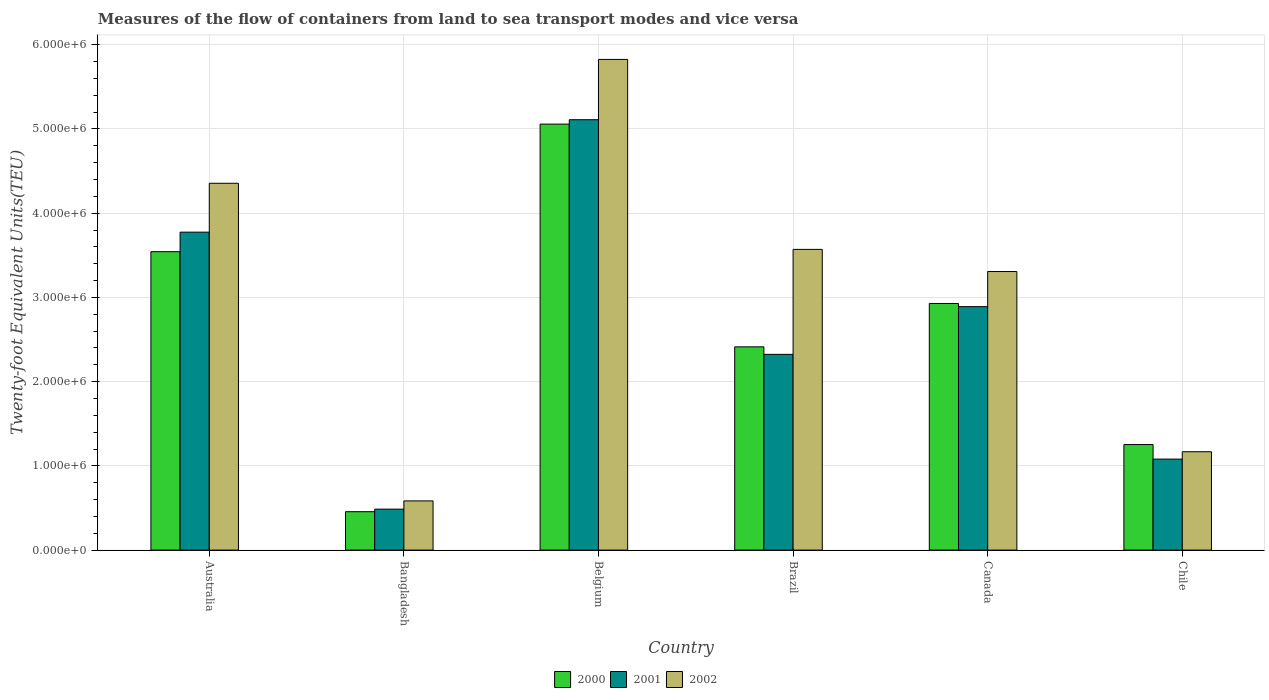How many groups of bars are there?
Give a very brief answer. 6. How many bars are there on the 2nd tick from the right?
Keep it short and to the point. 3. In how many cases, is the number of bars for a given country not equal to the number of legend labels?
Ensure brevity in your answer.  0. What is the container port traffic in 2002 in Belgium?
Provide a succinct answer. 5.83e+06. Across all countries, what is the maximum container port traffic in 2001?
Make the answer very short. 5.11e+06. Across all countries, what is the minimum container port traffic in 2000?
Make the answer very short. 4.56e+05. In which country was the container port traffic in 2001 maximum?
Your answer should be very brief. Belgium. In which country was the container port traffic in 2002 minimum?
Offer a very short reply. Bangladesh. What is the total container port traffic in 2002 in the graph?
Provide a succinct answer. 1.88e+07. What is the difference between the container port traffic in 2002 in Belgium and that in Brazil?
Offer a very short reply. 2.26e+06. What is the difference between the container port traffic in 2000 in Australia and the container port traffic in 2002 in Belgium?
Offer a very short reply. -2.28e+06. What is the average container port traffic in 2002 per country?
Make the answer very short. 3.14e+06. What is the difference between the container port traffic of/in 2001 and container port traffic of/in 2000 in Brazil?
Ensure brevity in your answer.  -8.93e+04. What is the ratio of the container port traffic in 2000 in Belgium to that in Canada?
Ensure brevity in your answer.  1.73. Is the container port traffic in 2000 in Australia less than that in Canada?
Your response must be concise. No. Is the difference between the container port traffic in 2001 in Bangladesh and Brazil greater than the difference between the container port traffic in 2000 in Bangladesh and Brazil?
Provide a succinct answer. Yes. What is the difference between the highest and the second highest container port traffic in 2002?
Your answer should be compact. 1.47e+06. What is the difference between the highest and the lowest container port traffic in 2000?
Provide a succinct answer. 4.60e+06. In how many countries, is the container port traffic in 2001 greater than the average container port traffic in 2001 taken over all countries?
Provide a succinct answer. 3. How many bars are there?
Offer a terse response. 18. How many countries are there in the graph?
Provide a succinct answer. 6. What is the difference between two consecutive major ticks on the Y-axis?
Your answer should be very brief. 1.00e+06. Are the values on the major ticks of Y-axis written in scientific E-notation?
Your answer should be very brief. Yes. Does the graph contain any zero values?
Make the answer very short. No. Where does the legend appear in the graph?
Offer a terse response. Bottom center. How many legend labels are there?
Offer a very short reply. 3. What is the title of the graph?
Keep it short and to the point. Measures of the flow of containers from land to sea transport modes and vice versa. Does "1965" appear as one of the legend labels in the graph?
Your answer should be compact. No. What is the label or title of the X-axis?
Provide a succinct answer. Country. What is the label or title of the Y-axis?
Ensure brevity in your answer.  Twenty-foot Equivalent Units(TEU). What is the Twenty-foot Equivalent Units(TEU) of 2000 in Australia?
Your response must be concise. 3.54e+06. What is the Twenty-foot Equivalent Units(TEU) of 2001 in Australia?
Provide a succinct answer. 3.77e+06. What is the Twenty-foot Equivalent Units(TEU) of 2002 in Australia?
Your response must be concise. 4.36e+06. What is the Twenty-foot Equivalent Units(TEU) in 2000 in Bangladesh?
Ensure brevity in your answer.  4.56e+05. What is the Twenty-foot Equivalent Units(TEU) in 2001 in Bangladesh?
Your response must be concise. 4.86e+05. What is the Twenty-foot Equivalent Units(TEU) in 2002 in Bangladesh?
Your answer should be very brief. 5.84e+05. What is the Twenty-foot Equivalent Units(TEU) in 2000 in Belgium?
Provide a succinct answer. 5.06e+06. What is the Twenty-foot Equivalent Units(TEU) in 2001 in Belgium?
Offer a very short reply. 5.11e+06. What is the Twenty-foot Equivalent Units(TEU) of 2002 in Belgium?
Your response must be concise. 5.83e+06. What is the Twenty-foot Equivalent Units(TEU) in 2000 in Brazil?
Provide a short and direct response. 2.41e+06. What is the Twenty-foot Equivalent Units(TEU) of 2001 in Brazil?
Offer a terse response. 2.32e+06. What is the Twenty-foot Equivalent Units(TEU) in 2002 in Brazil?
Give a very brief answer. 3.57e+06. What is the Twenty-foot Equivalent Units(TEU) in 2000 in Canada?
Your answer should be very brief. 2.93e+06. What is the Twenty-foot Equivalent Units(TEU) in 2001 in Canada?
Your answer should be compact. 2.89e+06. What is the Twenty-foot Equivalent Units(TEU) in 2002 in Canada?
Make the answer very short. 3.31e+06. What is the Twenty-foot Equivalent Units(TEU) in 2000 in Chile?
Keep it short and to the point. 1.25e+06. What is the Twenty-foot Equivalent Units(TEU) of 2001 in Chile?
Offer a terse response. 1.08e+06. What is the Twenty-foot Equivalent Units(TEU) in 2002 in Chile?
Provide a succinct answer. 1.17e+06. Across all countries, what is the maximum Twenty-foot Equivalent Units(TEU) in 2000?
Keep it short and to the point. 5.06e+06. Across all countries, what is the maximum Twenty-foot Equivalent Units(TEU) in 2001?
Offer a very short reply. 5.11e+06. Across all countries, what is the maximum Twenty-foot Equivalent Units(TEU) in 2002?
Give a very brief answer. 5.83e+06. Across all countries, what is the minimum Twenty-foot Equivalent Units(TEU) of 2000?
Offer a very short reply. 4.56e+05. Across all countries, what is the minimum Twenty-foot Equivalent Units(TEU) of 2001?
Give a very brief answer. 4.86e+05. Across all countries, what is the minimum Twenty-foot Equivalent Units(TEU) in 2002?
Ensure brevity in your answer.  5.84e+05. What is the total Twenty-foot Equivalent Units(TEU) in 2000 in the graph?
Offer a terse response. 1.57e+07. What is the total Twenty-foot Equivalent Units(TEU) of 2001 in the graph?
Offer a terse response. 1.57e+07. What is the total Twenty-foot Equivalent Units(TEU) of 2002 in the graph?
Your answer should be compact. 1.88e+07. What is the difference between the Twenty-foot Equivalent Units(TEU) in 2000 in Australia and that in Bangladesh?
Make the answer very short. 3.09e+06. What is the difference between the Twenty-foot Equivalent Units(TEU) of 2001 in Australia and that in Bangladesh?
Your answer should be very brief. 3.29e+06. What is the difference between the Twenty-foot Equivalent Units(TEU) in 2002 in Australia and that in Bangladesh?
Give a very brief answer. 3.77e+06. What is the difference between the Twenty-foot Equivalent Units(TEU) of 2000 in Australia and that in Belgium?
Offer a very short reply. -1.51e+06. What is the difference between the Twenty-foot Equivalent Units(TEU) of 2001 in Australia and that in Belgium?
Offer a terse response. -1.33e+06. What is the difference between the Twenty-foot Equivalent Units(TEU) in 2002 in Australia and that in Belgium?
Provide a short and direct response. -1.47e+06. What is the difference between the Twenty-foot Equivalent Units(TEU) of 2000 in Australia and that in Brazil?
Offer a terse response. 1.13e+06. What is the difference between the Twenty-foot Equivalent Units(TEU) in 2001 in Australia and that in Brazil?
Keep it short and to the point. 1.45e+06. What is the difference between the Twenty-foot Equivalent Units(TEU) in 2002 in Australia and that in Brazil?
Offer a very short reply. 7.85e+05. What is the difference between the Twenty-foot Equivalent Units(TEU) in 2000 in Australia and that in Canada?
Your answer should be compact. 6.15e+05. What is the difference between the Twenty-foot Equivalent Units(TEU) of 2001 in Australia and that in Canada?
Give a very brief answer. 8.84e+05. What is the difference between the Twenty-foot Equivalent Units(TEU) of 2002 in Australia and that in Canada?
Your answer should be compact. 1.05e+06. What is the difference between the Twenty-foot Equivalent Units(TEU) of 2000 in Australia and that in Chile?
Offer a very short reply. 2.29e+06. What is the difference between the Twenty-foot Equivalent Units(TEU) in 2001 in Australia and that in Chile?
Provide a succinct answer. 2.69e+06. What is the difference between the Twenty-foot Equivalent Units(TEU) in 2002 in Australia and that in Chile?
Your answer should be compact. 3.19e+06. What is the difference between the Twenty-foot Equivalent Units(TEU) of 2000 in Bangladesh and that in Belgium?
Provide a succinct answer. -4.60e+06. What is the difference between the Twenty-foot Equivalent Units(TEU) in 2001 in Bangladesh and that in Belgium?
Provide a short and direct response. -4.62e+06. What is the difference between the Twenty-foot Equivalent Units(TEU) of 2002 in Bangladesh and that in Belgium?
Offer a terse response. -5.24e+06. What is the difference between the Twenty-foot Equivalent Units(TEU) of 2000 in Bangladesh and that in Brazil?
Provide a short and direct response. -1.96e+06. What is the difference between the Twenty-foot Equivalent Units(TEU) of 2001 in Bangladesh and that in Brazil?
Give a very brief answer. -1.84e+06. What is the difference between the Twenty-foot Equivalent Units(TEU) in 2002 in Bangladesh and that in Brazil?
Your response must be concise. -2.99e+06. What is the difference between the Twenty-foot Equivalent Units(TEU) of 2000 in Bangladesh and that in Canada?
Your answer should be very brief. -2.47e+06. What is the difference between the Twenty-foot Equivalent Units(TEU) in 2001 in Bangladesh and that in Canada?
Give a very brief answer. -2.40e+06. What is the difference between the Twenty-foot Equivalent Units(TEU) of 2002 in Bangladesh and that in Canada?
Make the answer very short. -2.72e+06. What is the difference between the Twenty-foot Equivalent Units(TEU) of 2000 in Bangladesh and that in Chile?
Your answer should be compact. -7.97e+05. What is the difference between the Twenty-foot Equivalent Units(TEU) in 2001 in Bangladesh and that in Chile?
Keep it short and to the point. -5.94e+05. What is the difference between the Twenty-foot Equivalent Units(TEU) in 2002 in Bangladesh and that in Chile?
Keep it short and to the point. -5.84e+05. What is the difference between the Twenty-foot Equivalent Units(TEU) of 2000 in Belgium and that in Brazil?
Your answer should be very brief. 2.64e+06. What is the difference between the Twenty-foot Equivalent Units(TEU) of 2001 in Belgium and that in Brazil?
Your response must be concise. 2.79e+06. What is the difference between the Twenty-foot Equivalent Units(TEU) in 2002 in Belgium and that in Brazil?
Make the answer very short. 2.26e+06. What is the difference between the Twenty-foot Equivalent Units(TEU) in 2000 in Belgium and that in Canada?
Keep it short and to the point. 2.13e+06. What is the difference between the Twenty-foot Equivalent Units(TEU) in 2001 in Belgium and that in Canada?
Make the answer very short. 2.22e+06. What is the difference between the Twenty-foot Equivalent Units(TEU) of 2002 in Belgium and that in Canada?
Provide a short and direct response. 2.52e+06. What is the difference between the Twenty-foot Equivalent Units(TEU) in 2000 in Belgium and that in Chile?
Offer a terse response. 3.80e+06. What is the difference between the Twenty-foot Equivalent Units(TEU) of 2001 in Belgium and that in Chile?
Make the answer very short. 4.03e+06. What is the difference between the Twenty-foot Equivalent Units(TEU) of 2002 in Belgium and that in Chile?
Give a very brief answer. 4.66e+06. What is the difference between the Twenty-foot Equivalent Units(TEU) of 2000 in Brazil and that in Canada?
Ensure brevity in your answer.  -5.15e+05. What is the difference between the Twenty-foot Equivalent Units(TEU) in 2001 in Brazil and that in Canada?
Offer a very short reply. -5.67e+05. What is the difference between the Twenty-foot Equivalent Units(TEU) of 2002 in Brazil and that in Canada?
Make the answer very short. 2.63e+05. What is the difference between the Twenty-foot Equivalent Units(TEU) of 2000 in Brazil and that in Chile?
Your response must be concise. 1.16e+06. What is the difference between the Twenty-foot Equivalent Units(TEU) in 2001 in Brazil and that in Chile?
Offer a very short reply. 1.24e+06. What is the difference between the Twenty-foot Equivalent Units(TEU) of 2002 in Brazil and that in Chile?
Keep it short and to the point. 2.40e+06. What is the difference between the Twenty-foot Equivalent Units(TEU) of 2000 in Canada and that in Chile?
Ensure brevity in your answer.  1.67e+06. What is the difference between the Twenty-foot Equivalent Units(TEU) in 2001 in Canada and that in Chile?
Your answer should be very brief. 1.81e+06. What is the difference between the Twenty-foot Equivalent Units(TEU) of 2002 in Canada and that in Chile?
Offer a very short reply. 2.14e+06. What is the difference between the Twenty-foot Equivalent Units(TEU) in 2000 in Australia and the Twenty-foot Equivalent Units(TEU) in 2001 in Bangladesh?
Make the answer very short. 3.06e+06. What is the difference between the Twenty-foot Equivalent Units(TEU) of 2000 in Australia and the Twenty-foot Equivalent Units(TEU) of 2002 in Bangladesh?
Provide a short and direct response. 2.96e+06. What is the difference between the Twenty-foot Equivalent Units(TEU) in 2001 in Australia and the Twenty-foot Equivalent Units(TEU) in 2002 in Bangladesh?
Offer a very short reply. 3.19e+06. What is the difference between the Twenty-foot Equivalent Units(TEU) of 2000 in Australia and the Twenty-foot Equivalent Units(TEU) of 2001 in Belgium?
Your answer should be very brief. -1.57e+06. What is the difference between the Twenty-foot Equivalent Units(TEU) in 2000 in Australia and the Twenty-foot Equivalent Units(TEU) in 2002 in Belgium?
Your answer should be very brief. -2.28e+06. What is the difference between the Twenty-foot Equivalent Units(TEU) of 2001 in Australia and the Twenty-foot Equivalent Units(TEU) of 2002 in Belgium?
Make the answer very short. -2.05e+06. What is the difference between the Twenty-foot Equivalent Units(TEU) in 2000 in Australia and the Twenty-foot Equivalent Units(TEU) in 2001 in Brazil?
Your response must be concise. 1.22e+06. What is the difference between the Twenty-foot Equivalent Units(TEU) of 2000 in Australia and the Twenty-foot Equivalent Units(TEU) of 2002 in Brazil?
Your answer should be very brief. -2.75e+04. What is the difference between the Twenty-foot Equivalent Units(TEU) of 2001 in Australia and the Twenty-foot Equivalent Units(TEU) of 2002 in Brazil?
Offer a very short reply. 2.05e+05. What is the difference between the Twenty-foot Equivalent Units(TEU) of 2000 in Australia and the Twenty-foot Equivalent Units(TEU) of 2001 in Canada?
Offer a terse response. 6.52e+05. What is the difference between the Twenty-foot Equivalent Units(TEU) in 2000 in Australia and the Twenty-foot Equivalent Units(TEU) in 2002 in Canada?
Ensure brevity in your answer.  2.35e+05. What is the difference between the Twenty-foot Equivalent Units(TEU) in 2001 in Australia and the Twenty-foot Equivalent Units(TEU) in 2002 in Canada?
Offer a very short reply. 4.68e+05. What is the difference between the Twenty-foot Equivalent Units(TEU) of 2000 in Australia and the Twenty-foot Equivalent Units(TEU) of 2001 in Chile?
Provide a short and direct response. 2.46e+06. What is the difference between the Twenty-foot Equivalent Units(TEU) in 2000 in Australia and the Twenty-foot Equivalent Units(TEU) in 2002 in Chile?
Provide a short and direct response. 2.37e+06. What is the difference between the Twenty-foot Equivalent Units(TEU) in 2001 in Australia and the Twenty-foot Equivalent Units(TEU) in 2002 in Chile?
Provide a short and direct response. 2.61e+06. What is the difference between the Twenty-foot Equivalent Units(TEU) of 2000 in Bangladesh and the Twenty-foot Equivalent Units(TEU) of 2001 in Belgium?
Offer a terse response. -4.65e+06. What is the difference between the Twenty-foot Equivalent Units(TEU) in 2000 in Bangladesh and the Twenty-foot Equivalent Units(TEU) in 2002 in Belgium?
Offer a terse response. -5.37e+06. What is the difference between the Twenty-foot Equivalent Units(TEU) in 2001 in Bangladesh and the Twenty-foot Equivalent Units(TEU) in 2002 in Belgium?
Offer a terse response. -5.34e+06. What is the difference between the Twenty-foot Equivalent Units(TEU) of 2000 in Bangladesh and the Twenty-foot Equivalent Units(TEU) of 2001 in Brazil?
Provide a succinct answer. -1.87e+06. What is the difference between the Twenty-foot Equivalent Units(TEU) of 2000 in Bangladesh and the Twenty-foot Equivalent Units(TEU) of 2002 in Brazil?
Provide a short and direct response. -3.11e+06. What is the difference between the Twenty-foot Equivalent Units(TEU) in 2001 in Bangladesh and the Twenty-foot Equivalent Units(TEU) in 2002 in Brazil?
Ensure brevity in your answer.  -3.08e+06. What is the difference between the Twenty-foot Equivalent Units(TEU) of 2000 in Bangladesh and the Twenty-foot Equivalent Units(TEU) of 2001 in Canada?
Your response must be concise. -2.43e+06. What is the difference between the Twenty-foot Equivalent Units(TEU) of 2000 in Bangladesh and the Twenty-foot Equivalent Units(TEU) of 2002 in Canada?
Your answer should be compact. -2.85e+06. What is the difference between the Twenty-foot Equivalent Units(TEU) in 2001 in Bangladesh and the Twenty-foot Equivalent Units(TEU) in 2002 in Canada?
Give a very brief answer. -2.82e+06. What is the difference between the Twenty-foot Equivalent Units(TEU) of 2000 in Bangladesh and the Twenty-foot Equivalent Units(TEU) of 2001 in Chile?
Your answer should be very brief. -6.25e+05. What is the difference between the Twenty-foot Equivalent Units(TEU) of 2000 in Bangladesh and the Twenty-foot Equivalent Units(TEU) of 2002 in Chile?
Offer a terse response. -7.12e+05. What is the difference between the Twenty-foot Equivalent Units(TEU) of 2001 in Bangladesh and the Twenty-foot Equivalent Units(TEU) of 2002 in Chile?
Give a very brief answer. -6.82e+05. What is the difference between the Twenty-foot Equivalent Units(TEU) in 2000 in Belgium and the Twenty-foot Equivalent Units(TEU) in 2001 in Brazil?
Your answer should be compact. 2.73e+06. What is the difference between the Twenty-foot Equivalent Units(TEU) of 2000 in Belgium and the Twenty-foot Equivalent Units(TEU) of 2002 in Brazil?
Give a very brief answer. 1.49e+06. What is the difference between the Twenty-foot Equivalent Units(TEU) in 2001 in Belgium and the Twenty-foot Equivalent Units(TEU) in 2002 in Brazil?
Provide a succinct answer. 1.54e+06. What is the difference between the Twenty-foot Equivalent Units(TEU) in 2000 in Belgium and the Twenty-foot Equivalent Units(TEU) in 2001 in Canada?
Your response must be concise. 2.17e+06. What is the difference between the Twenty-foot Equivalent Units(TEU) in 2000 in Belgium and the Twenty-foot Equivalent Units(TEU) in 2002 in Canada?
Your answer should be very brief. 1.75e+06. What is the difference between the Twenty-foot Equivalent Units(TEU) in 2001 in Belgium and the Twenty-foot Equivalent Units(TEU) in 2002 in Canada?
Keep it short and to the point. 1.80e+06. What is the difference between the Twenty-foot Equivalent Units(TEU) in 2000 in Belgium and the Twenty-foot Equivalent Units(TEU) in 2001 in Chile?
Offer a terse response. 3.98e+06. What is the difference between the Twenty-foot Equivalent Units(TEU) of 2000 in Belgium and the Twenty-foot Equivalent Units(TEU) of 2002 in Chile?
Keep it short and to the point. 3.89e+06. What is the difference between the Twenty-foot Equivalent Units(TEU) in 2001 in Belgium and the Twenty-foot Equivalent Units(TEU) in 2002 in Chile?
Your answer should be compact. 3.94e+06. What is the difference between the Twenty-foot Equivalent Units(TEU) of 2000 in Brazil and the Twenty-foot Equivalent Units(TEU) of 2001 in Canada?
Your answer should be compact. -4.77e+05. What is the difference between the Twenty-foot Equivalent Units(TEU) in 2000 in Brazil and the Twenty-foot Equivalent Units(TEU) in 2002 in Canada?
Provide a succinct answer. -8.94e+05. What is the difference between the Twenty-foot Equivalent Units(TEU) in 2001 in Brazil and the Twenty-foot Equivalent Units(TEU) in 2002 in Canada?
Offer a very short reply. -9.84e+05. What is the difference between the Twenty-foot Equivalent Units(TEU) in 2000 in Brazil and the Twenty-foot Equivalent Units(TEU) in 2001 in Chile?
Make the answer very short. 1.33e+06. What is the difference between the Twenty-foot Equivalent Units(TEU) of 2000 in Brazil and the Twenty-foot Equivalent Units(TEU) of 2002 in Chile?
Give a very brief answer. 1.25e+06. What is the difference between the Twenty-foot Equivalent Units(TEU) in 2001 in Brazil and the Twenty-foot Equivalent Units(TEU) in 2002 in Chile?
Ensure brevity in your answer.  1.16e+06. What is the difference between the Twenty-foot Equivalent Units(TEU) of 2000 in Canada and the Twenty-foot Equivalent Units(TEU) of 2001 in Chile?
Give a very brief answer. 1.85e+06. What is the difference between the Twenty-foot Equivalent Units(TEU) of 2000 in Canada and the Twenty-foot Equivalent Units(TEU) of 2002 in Chile?
Provide a succinct answer. 1.76e+06. What is the difference between the Twenty-foot Equivalent Units(TEU) in 2001 in Canada and the Twenty-foot Equivalent Units(TEU) in 2002 in Chile?
Offer a terse response. 1.72e+06. What is the average Twenty-foot Equivalent Units(TEU) in 2000 per country?
Give a very brief answer. 2.61e+06. What is the average Twenty-foot Equivalent Units(TEU) in 2001 per country?
Your answer should be compact. 2.61e+06. What is the average Twenty-foot Equivalent Units(TEU) of 2002 per country?
Your response must be concise. 3.14e+06. What is the difference between the Twenty-foot Equivalent Units(TEU) of 2000 and Twenty-foot Equivalent Units(TEU) of 2001 in Australia?
Offer a terse response. -2.32e+05. What is the difference between the Twenty-foot Equivalent Units(TEU) of 2000 and Twenty-foot Equivalent Units(TEU) of 2002 in Australia?
Ensure brevity in your answer.  -8.12e+05. What is the difference between the Twenty-foot Equivalent Units(TEU) in 2001 and Twenty-foot Equivalent Units(TEU) in 2002 in Australia?
Offer a terse response. -5.80e+05. What is the difference between the Twenty-foot Equivalent Units(TEU) of 2000 and Twenty-foot Equivalent Units(TEU) of 2001 in Bangladesh?
Ensure brevity in your answer.  -3.03e+04. What is the difference between the Twenty-foot Equivalent Units(TEU) of 2000 and Twenty-foot Equivalent Units(TEU) of 2002 in Bangladesh?
Your answer should be compact. -1.28e+05. What is the difference between the Twenty-foot Equivalent Units(TEU) of 2001 and Twenty-foot Equivalent Units(TEU) of 2002 in Bangladesh?
Your answer should be compact. -9.79e+04. What is the difference between the Twenty-foot Equivalent Units(TEU) in 2000 and Twenty-foot Equivalent Units(TEU) in 2001 in Belgium?
Give a very brief answer. -5.21e+04. What is the difference between the Twenty-foot Equivalent Units(TEU) of 2000 and Twenty-foot Equivalent Units(TEU) of 2002 in Belgium?
Your response must be concise. -7.68e+05. What is the difference between the Twenty-foot Equivalent Units(TEU) in 2001 and Twenty-foot Equivalent Units(TEU) in 2002 in Belgium?
Offer a terse response. -7.16e+05. What is the difference between the Twenty-foot Equivalent Units(TEU) in 2000 and Twenty-foot Equivalent Units(TEU) in 2001 in Brazil?
Provide a short and direct response. 8.93e+04. What is the difference between the Twenty-foot Equivalent Units(TEU) of 2000 and Twenty-foot Equivalent Units(TEU) of 2002 in Brazil?
Ensure brevity in your answer.  -1.16e+06. What is the difference between the Twenty-foot Equivalent Units(TEU) of 2001 and Twenty-foot Equivalent Units(TEU) of 2002 in Brazil?
Keep it short and to the point. -1.25e+06. What is the difference between the Twenty-foot Equivalent Units(TEU) in 2000 and Twenty-foot Equivalent Units(TEU) in 2001 in Canada?
Your answer should be compact. 3.76e+04. What is the difference between the Twenty-foot Equivalent Units(TEU) of 2000 and Twenty-foot Equivalent Units(TEU) of 2002 in Canada?
Your answer should be very brief. -3.79e+05. What is the difference between the Twenty-foot Equivalent Units(TEU) of 2001 and Twenty-foot Equivalent Units(TEU) of 2002 in Canada?
Provide a succinct answer. -4.17e+05. What is the difference between the Twenty-foot Equivalent Units(TEU) of 2000 and Twenty-foot Equivalent Units(TEU) of 2001 in Chile?
Keep it short and to the point. 1.73e+05. What is the difference between the Twenty-foot Equivalent Units(TEU) of 2000 and Twenty-foot Equivalent Units(TEU) of 2002 in Chile?
Your answer should be compact. 8.53e+04. What is the difference between the Twenty-foot Equivalent Units(TEU) of 2001 and Twenty-foot Equivalent Units(TEU) of 2002 in Chile?
Make the answer very short. -8.73e+04. What is the ratio of the Twenty-foot Equivalent Units(TEU) in 2000 in Australia to that in Bangladesh?
Your answer should be compact. 7.77. What is the ratio of the Twenty-foot Equivalent Units(TEU) in 2001 in Australia to that in Bangladesh?
Ensure brevity in your answer.  7.76. What is the ratio of the Twenty-foot Equivalent Units(TEU) of 2002 in Australia to that in Bangladesh?
Your response must be concise. 7.45. What is the ratio of the Twenty-foot Equivalent Units(TEU) in 2000 in Australia to that in Belgium?
Give a very brief answer. 0.7. What is the ratio of the Twenty-foot Equivalent Units(TEU) in 2001 in Australia to that in Belgium?
Your answer should be compact. 0.74. What is the ratio of the Twenty-foot Equivalent Units(TEU) of 2002 in Australia to that in Belgium?
Provide a short and direct response. 0.75. What is the ratio of the Twenty-foot Equivalent Units(TEU) of 2000 in Australia to that in Brazil?
Keep it short and to the point. 1.47. What is the ratio of the Twenty-foot Equivalent Units(TEU) of 2001 in Australia to that in Brazil?
Offer a very short reply. 1.62. What is the ratio of the Twenty-foot Equivalent Units(TEU) in 2002 in Australia to that in Brazil?
Your answer should be compact. 1.22. What is the ratio of the Twenty-foot Equivalent Units(TEU) in 2000 in Australia to that in Canada?
Provide a succinct answer. 1.21. What is the ratio of the Twenty-foot Equivalent Units(TEU) of 2001 in Australia to that in Canada?
Your response must be concise. 1.31. What is the ratio of the Twenty-foot Equivalent Units(TEU) in 2002 in Australia to that in Canada?
Ensure brevity in your answer.  1.32. What is the ratio of the Twenty-foot Equivalent Units(TEU) of 2000 in Australia to that in Chile?
Provide a succinct answer. 2.83. What is the ratio of the Twenty-foot Equivalent Units(TEU) of 2001 in Australia to that in Chile?
Provide a succinct answer. 3.49. What is the ratio of the Twenty-foot Equivalent Units(TEU) in 2002 in Australia to that in Chile?
Provide a succinct answer. 3.73. What is the ratio of the Twenty-foot Equivalent Units(TEU) in 2000 in Bangladesh to that in Belgium?
Offer a very short reply. 0.09. What is the ratio of the Twenty-foot Equivalent Units(TEU) of 2001 in Bangladesh to that in Belgium?
Your response must be concise. 0.1. What is the ratio of the Twenty-foot Equivalent Units(TEU) of 2002 in Bangladesh to that in Belgium?
Provide a short and direct response. 0.1. What is the ratio of the Twenty-foot Equivalent Units(TEU) of 2000 in Bangladesh to that in Brazil?
Your response must be concise. 0.19. What is the ratio of the Twenty-foot Equivalent Units(TEU) of 2001 in Bangladesh to that in Brazil?
Your response must be concise. 0.21. What is the ratio of the Twenty-foot Equivalent Units(TEU) in 2002 in Bangladesh to that in Brazil?
Offer a very short reply. 0.16. What is the ratio of the Twenty-foot Equivalent Units(TEU) in 2000 in Bangladesh to that in Canada?
Provide a short and direct response. 0.16. What is the ratio of the Twenty-foot Equivalent Units(TEU) of 2001 in Bangladesh to that in Canada?
Give a very brief answer. 0.17. What is the ratio of the Twenty-foot Equivalent Units(TEU) in 2002 in Bangladesh to that in Canada?
Give a very brief answer. 0.18. What is the ratio of the Twenty-foot Equivalent Units(TEU) of 2000 in Bangladesh to that in Chile?
Your answer should be compact. 0.36. What is the ratio of the Twenty-foot Equivalent Units(TEU) of 2001 in Bangladesh to that in Chile?
Offer a terse response. 0.45. What is the ratio of the Twenty-foot Equivalent Units(TEU) in 2002 in Bangladesh to that in Chile?
Your response must be concise. 0.5. What is the ratio of the Twenty-foot Equivalent Units(TEU) in 2000 in Belgium to that in Brazil?
Your answer should be very brief. 2.1. What is the ratio of the Twenty-foot Equivalent Units(TEU) of 2001 in Belgium to that in Brazil?
Provide a short and direct response. 2.2. What is the ratio of the Twenty-foot Equivalent Units(TEU) of 2002 in Belgium to that in Brazil?
Offer a terse response. 1.63. What is the ratio of the Twenty-foot Equivalent Units(TEU) in 2000 in Belgium to that in Canada?
Make the answer very short. 1.73. What is the ratio of the Twenty-foot Equivalent Units(TEU) of 2001 in Belgium to that in Canada?
Your answer should be very brief. 1.77. What is the ratio of the Twenty-foot Equivalent Units(TEU) in 2002 in Belgium to that in Canada?
Provide a succinct answer. 1.76. What is the ratio of the Twenty-foot Equivalent Units(TEU) in 2000 in Belgium to that in Chile?
Keep it short and to the point. 4.04. What is the ratio of the Twenty-foot Equivalent Units(TEU) in 2001 in Belgium to that in Chile?
Give a very brief answer. 4.73. What is the ratio of the Twenty-foot Equivalent Units(TEU) of 2002 in Belgium to that in Chile?
Your response must be concise. 4.99. What is the ratio of the Twenty-foot Equivalent Units(TEU) of 2000 in Brazil to that in Canada?
Your answer should be compact. 0.82. What is the ratio of the Twenty-foot Equivalent Units(TEU) of 2001 in Brazil to that in Canada?
Offer a very short reply. 0.8. What is the ratio of the Twenty-foot Equivalent Units(TEU) of 2002 in Brazil to that in Canada?
Offer a very short reply. 1.08. What is the ratio of the Twenty-foot Equivalent Units(TEU) in 2000 in Brazil to that in Chile?
Give a very brief answer. 1.93. What is the ratio of the Twenty-foot Equivalent Units(TEU) in 2001 in Brazil to that in Chile?
Give a very brief answer. 2.15. What is the ratio of the Twenty-foot Equivalent Units(TEU) of 2002 in Brazil to that in Chile?
Make the answer very short. 3.06. What is the ratio of the Twenty-foot Equivalent Units(TEU) of 2000 in Canada to that in Chile?
Your response must be concise. 2.34. What is the ratio of the Twenty-foot Equivalent Units(TEU) of 2001 in Canada to that in Chile?
Ensure brevity in your answer.  2.67. What is the ratio of the Twenty-foot Equivalent Units(TEU) in 2002 in Canada to that in Chile?
Keep it short and to the point. 2.83. What is the difference between the highest and the second highest Twenty-foot Equivalent Units(TEU) of 2000?
Your answer should be compact. 1.51e+06. What is the difference between the highest and the second highest Twenty-foot Equivalent Units(TEU) in 2001?
Provide a succinct answer. 1.33e+06. What is the difference between the highest and the second highest Twenty-foot Equivalent Units(TEU) of 2002?
Offer a terse response. 1.47e+06. What is the difference between the highest and the lowest Twenty-foot Equivalent Units(TEU) of 2000?
Provide a short and direct response. 4.60e+06. What is the difference between the highest and the lowest Twenty-foot Equivalent Units(TEU) in 2001?
Offer a terse response. 4.62e+06. What is the difference between the highest and the lowest Twenty-foot Equivalent Units(TEU) in 2002?
Offer a terse response. 5.24e+06. 